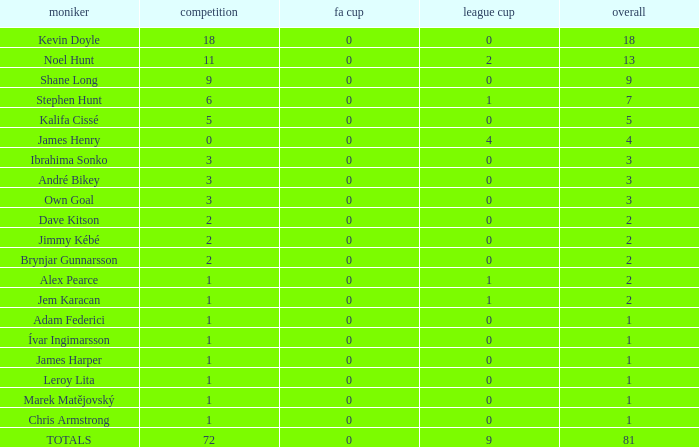What is the championship of Jem Karacan that has a total of 2 and a league cup more than 0? 1.0. 